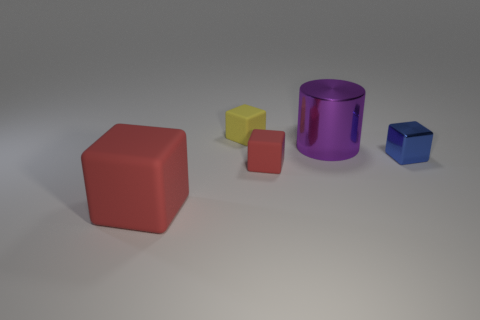What is the shape of the tiny red matte thing?
Your response must be concise. Cube. The other matte object that is the same color as the big matte thing is what size?
Your answer should be very brief. Small. What is the size of the red cube that is to the right of the big thing that is in front of the big purple cylinder?
Provide a succinct answer. Small. There is a block that is behind the small metallic object; what size is it?
Give a very brief answer. Small. Is the number of purple shiny things on the left side of the tiny red object less than the number of cubes that are behind the metallic cylinder?
Your answer should be very brief. Yes. The shiny cube is what color?
Make the answer very short. Blue. Are there any metallic cubes that have the same color as the shiny cylinder?
Provide a short and direct response. No. What shape is the red rubber object on the right side of the red object that is on the left side of the small rubber object in front of the yellow object?
Offer a terse response. Cube. There is a tiny block to the right of the large purple metallic cylinder; what is it made of?
Keep it short and to the point. Metal. How big is the red cube to the left of the matte object that is behind the tiny rubber cube in front of the small metallic thing?
Your answer should be very brief. Large. 